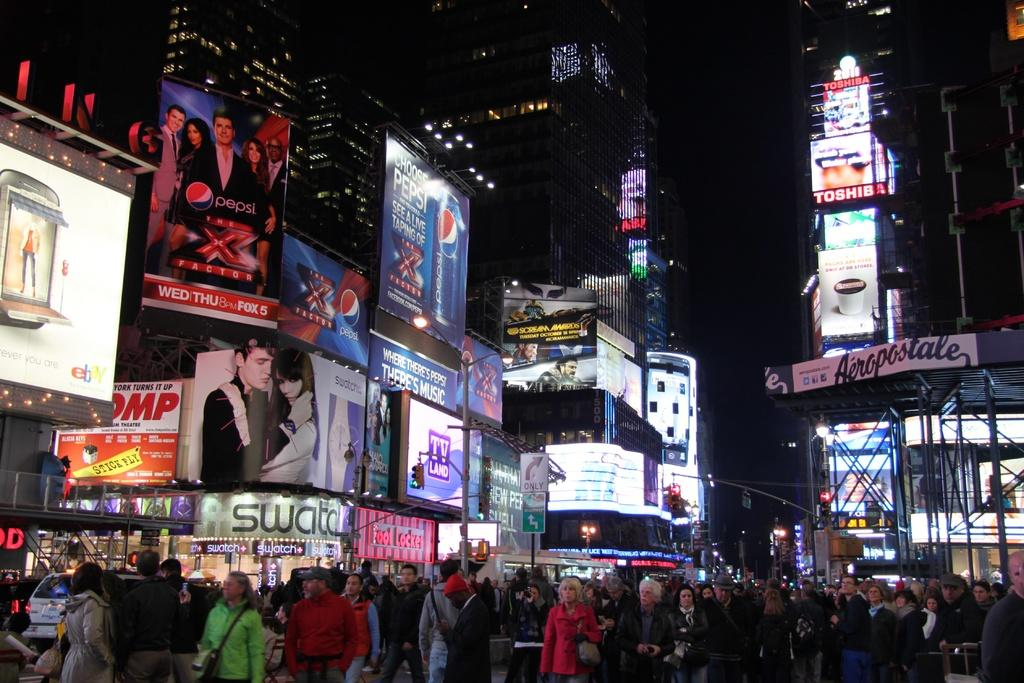<image>
Relay a brief, clear account of the picture shown. A billboard that says Choose Pepsi hangs above a very crowded downtown street. 